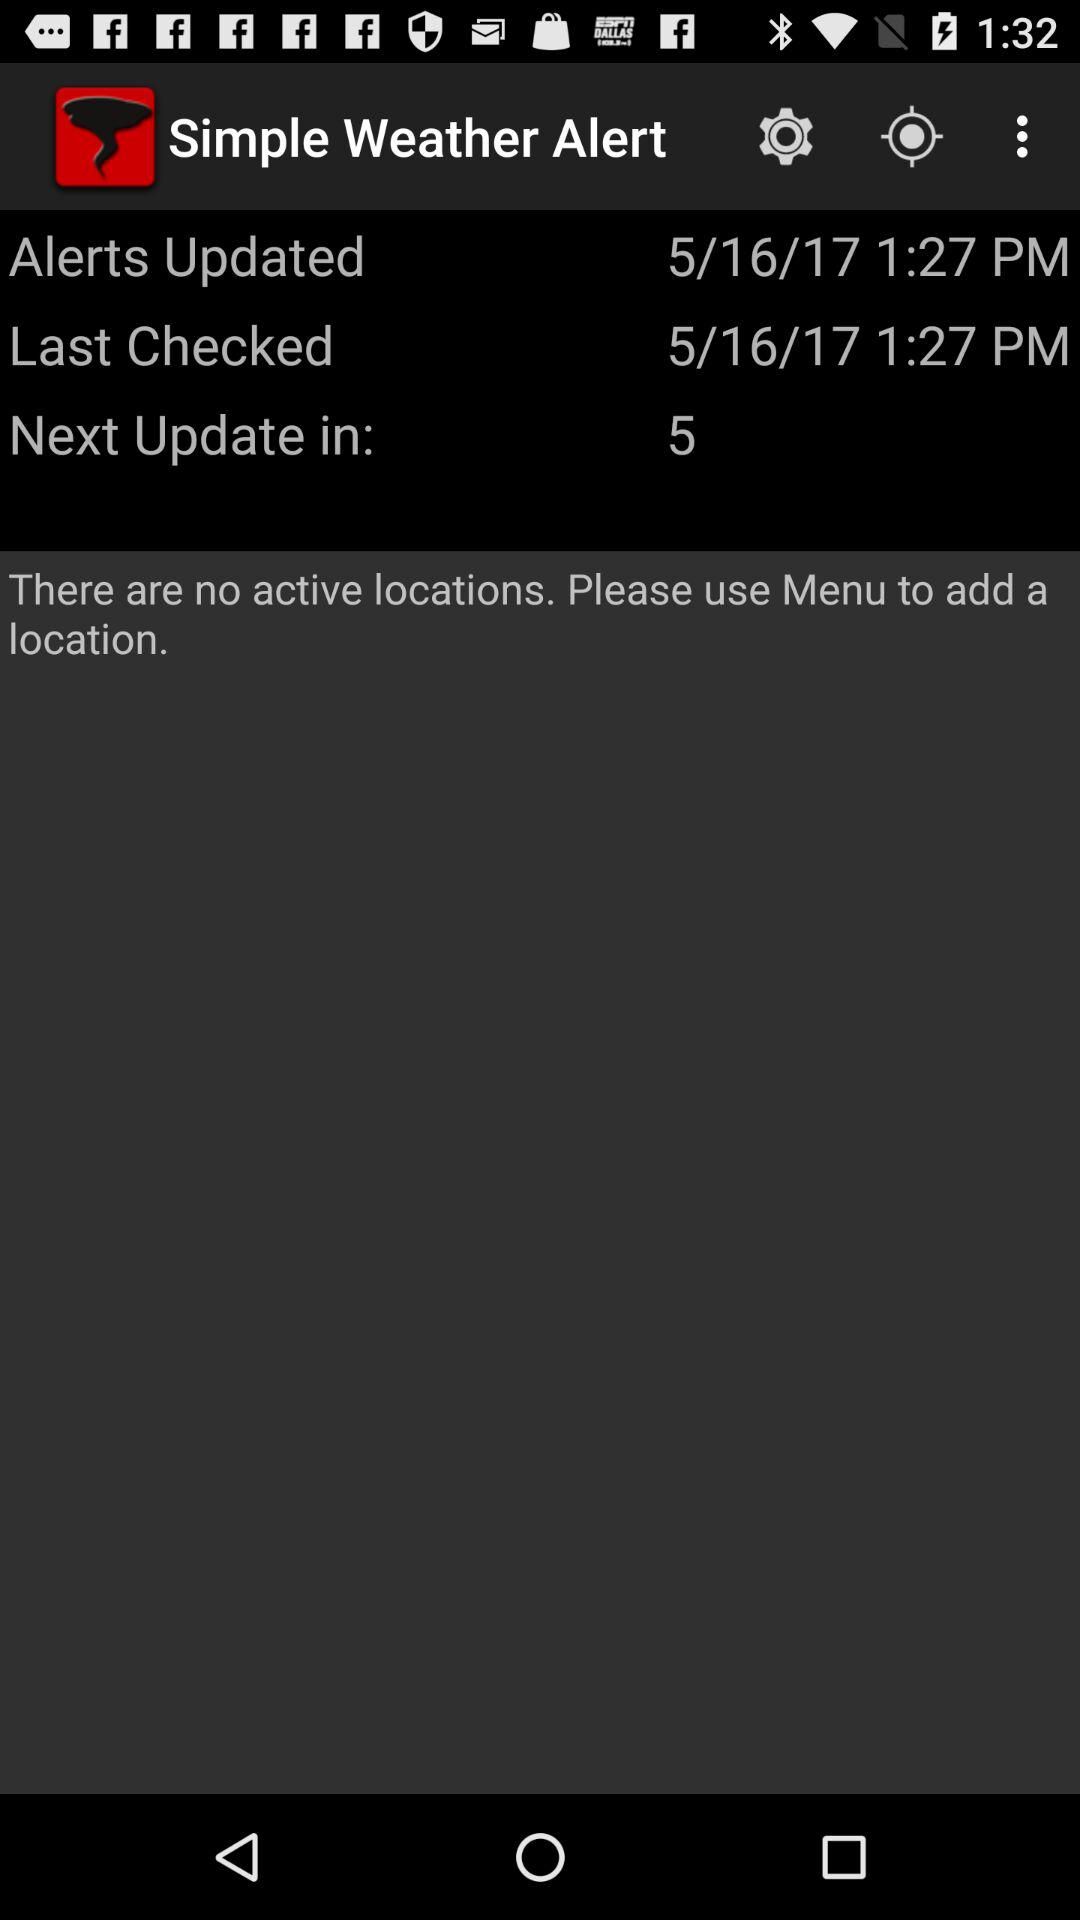How many active locations are there right now? There are no active locations right now. 